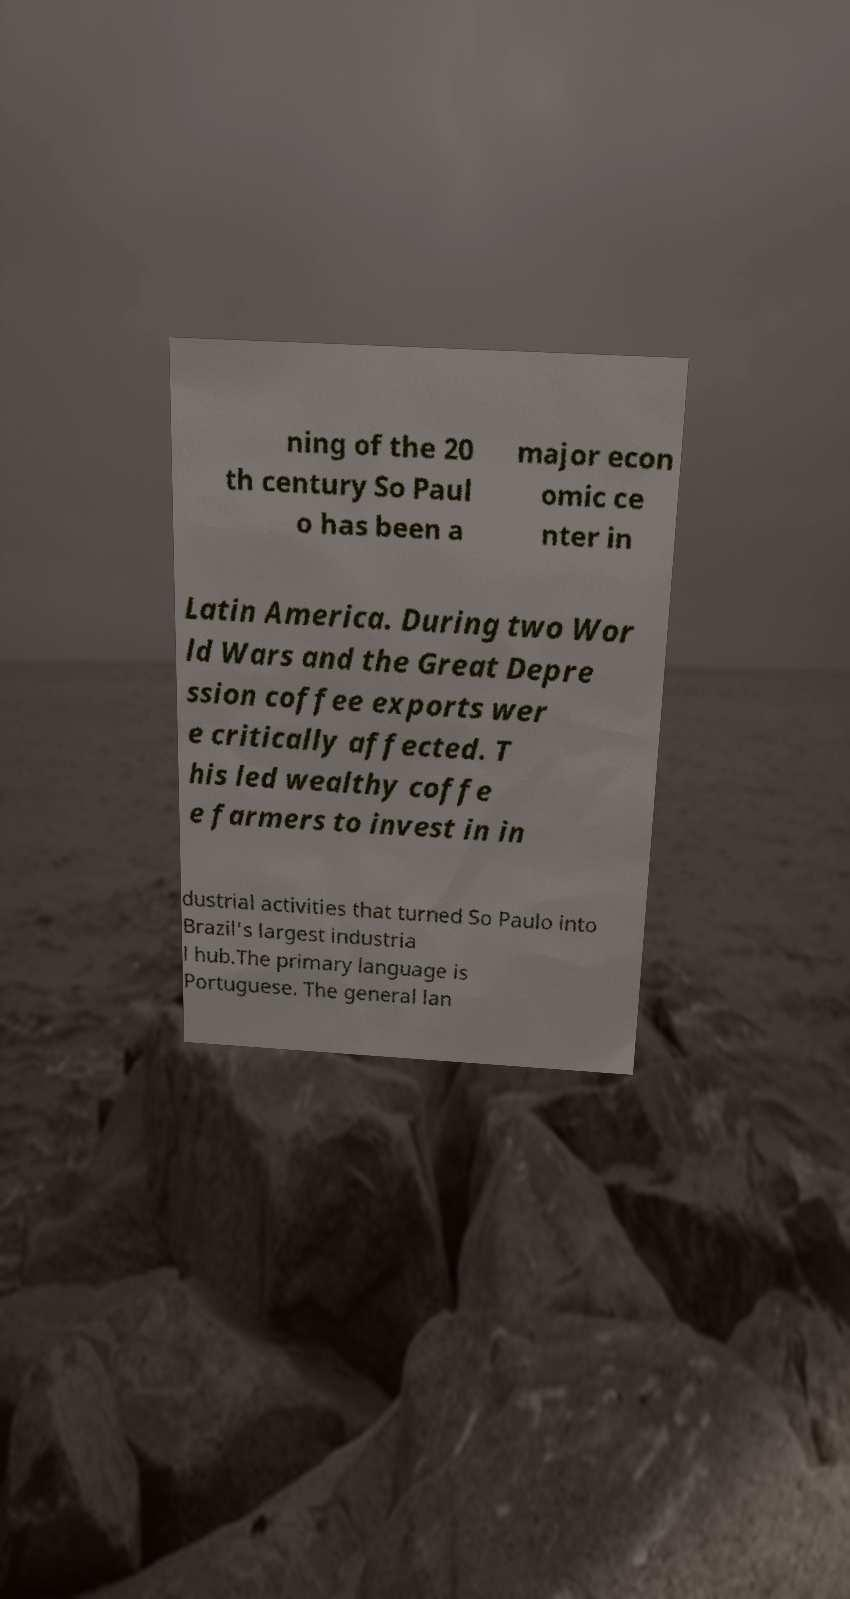Can you accurately transcribe the text from the provided image for me? ning of the 20 th century So Paul o has been a major econ omic ce nter in Latin America. During two Wor ld Wars and the Great Depre ssion coffee exports wer e critically affected. T his led wealthy coffe e farmers to invest in in dustrial activities that turned So Paulo into Brazil's largest industria l hub.The primary language is Portuguese. The general lan 